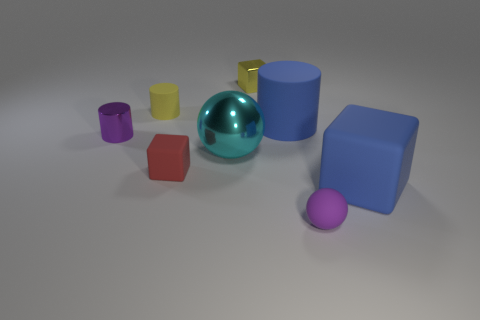Does the cyan object have the same size as the blue matte cube?
Provide a short and direct response. Yes. What is the material of the large cylinder?
Give a very brief answer. Rubber. What is the material of the other cylinder that is the same size as the yellow rubber cylinder?
Keep it short and to the point. Metal. Are there any cubes that have the same size as the blue matte cylinder?
Give a very brief answer. Yes. Is the number of rubber blocks that are to the right of the red matte object the same as the number of cyan shiny spheres that are in front of the yellow rubber object?
Offer a very short reply. Yes. Are there more big rubber cubes than tiny green rubber spheres?
Offer a very short reply. Yes. How many metallic objects are tiny yellow things or tiny red cubes?
Offer a very short reply. 1. What number of metallic cylinders are the same color as the matte ball?
Your answer should be very brief. 1. There is a purple thing that is to the left of the tiny cube that is in front of the yellow thing that is to the left of the red object; what is it made of?
Give a very brief answer. Metal. There is a cylinder left of the rubber cylinder left of the tiny yellow cube; what color is it?
Give a very brief answer. Purple. 